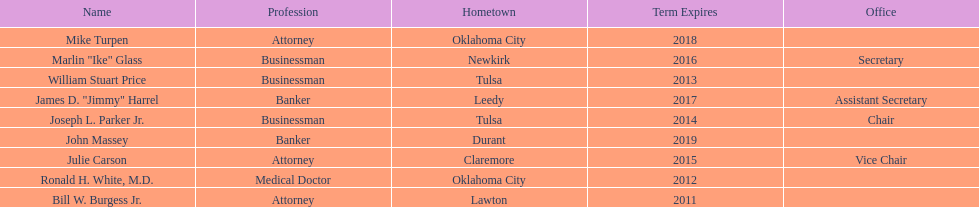How many members had businessman listed as their profession? 3. 